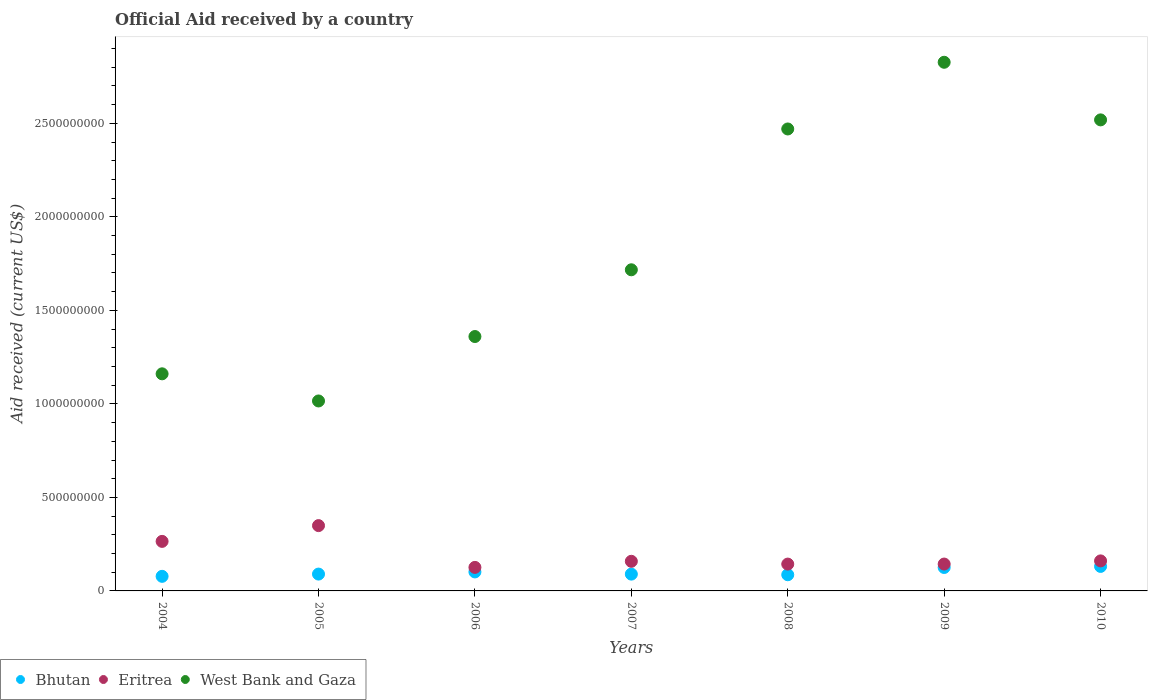How many different coloured dotlines are there?
Ensure brevity in your answer.  3. What is the net official aid received in West Bank and Gaza in 2007?
Provide a succinct answer. 1.72e+09. Across all years, what is the maximum net official aid received in Eritrea?
Give a very brief answer. 3.49e+08. Across all years, what is the minimum net official aid received in West Bank and Gaza?
Ensure brevity in your answer.  1.02e+09. In which year was the net official aid received in Eritrea minimum?
Keep it short and to the point. 2006. What is the total net official aid received in Eritrea in the graph?
Your answer should be compact. 1.35e+09. What is the difference between the net official aid received in Eritrea in 2007 and that in 2009?
Keep it short and to the point. 1.47e+07. What is the difference between the net official aid received in Eritrea in 2006 and the net official aid received in Bhutan in 2004?
Provide a short and direct response. 4.78e+07. What is the average net official aid received in West Bank and Gaza per year?
Offer a terse response. 1.87e+09. In the year 2009, what is the difference between the net official aid received in Eritrea and net official aid received in Bhutan?
Provide a succinct answer. 1.83e+07. What is the ratio of the net official aid received in West Bank and Gaza in 2005 to that in 2009?
Provide a short and direct response. 0.36. What is the difference between the highest and the second highest net official aid received in West Bank and Gaza?
Keep it short and to the point. 3.08e+08. What is the difference between the highest and the lowest net official aid received in Bhutan?
Offer a terse response. 5.30e+07. Is the sum of the net official aid received in Bhutan in 2005 and 2008 greater than the maximum net official aid received in West Bank and Gaza across all years?
Your response must be concise. No. Is it the case that in every year, the sum of the net official aid received in Eritrea and net official aid received in Bhutan  is greater than the net official aid received in West Bank and Gaza?
Your response must be concise. No. Is the net official aid received in Bhutan strictly less than the net official aid received in Eritrea over the years?
Give a very brief answer. Yes. How many dotlines are there?
Your answer should be very brief. 3. What is the difference between two consecutive major ticks on the Y-axis?
Give a very brief answer. 5.00e+08. Does the graph contain any zero values?
Offer a very short reply. No. Does the graph contain grids?
Offer a terse response. No. How many legend labels are there?
Ensure brevity in your answer.  3. What is the title of the graph?
Provide a succinct answer. Official Aid received by a country. Does "Cabo Verde" appear as one of the legend labels in the graph?
Give a very brief answer. No. What is the label or title of the Y-axis?
Keep it short and to the point. Aid received (current US$). What is the Aid received (current US$) in Bhutan in 2004?
Make the answer very short. 7.80e+07. What is the Aid received (current US$) in Eritrea in 2004?
Offer a terse response. 2.65e+08. What is the Aid received (current US$) in West Bank and Gaza in 2004?
Your response must be concise. 1.16e+09. What is the Aid received (current US$) of Bhutan in 2005?
Provide a succinct answer. 9.00e+07. What is the Aid received (current US$) in Eritrea in 2005?
Your answer should be compact. 3.49e+08. What is the Aid received (current US$) of West Bank and Gaza in 2005?
Offer a terse response. 1.02e+09. What is the Aid received (current US$) in Bhutan in 2006?
Give a very brief answer. 1.02e+08. What is the Aid received (current US$) of Eritrea in 2006?
Provide a short and direct response. 1.26e+08. What is the Aid received (current US$) of West Bank and Gaza in 2006?
Provide a succinct answer. 1.36e+09. What is the Aid received (current US$) in Bhutan in 2007?
Keep it short and to the point. 8.98e+07. What is the Aid received (current US$) in Eritrea in 2007?
Make the answer very short. 1.58e+08. What is the Aid received (current US$) in West Bank and Gaza in 2007?
Offer a very short reply. 1.72e+09. What is the Aid received (current US$) of Bhutan in 2008?
Provide a succinct answer. 8.65e+07. What is the Aid received (current US$) of Eritrea in 2008?
Offer a terse response. 1.43e+08. What is the Aid received (current US$) of West Bank and Gaza in 2008?
Make the answer very short. 2.47e+09. What is the Aid received (current US$) of Bhutan in 2009?
Your answer should be very brief. 1.25e+08. What is the Aid received (current US$) of Eritrea in 2009?
Provide a succinct answer. 1.44e+08. What is the Aid received (current US$) in West Bank and Gaza in 2009?
Make the answer very short. 2.83e+09. What is the Aid received (current US$) in Bhutan in 2010?
Give a very brief answer. 1.31e+08. What is the Aid received (current US$) of Eritrea in 2010?
Keep it short and to the point. 1.61e+08. What is the Aid received (current US$) in West Bank and Gaza in 2010?
Offer a very short reply. 2.52e+09. Across all years, what is the maximum Aid received (current US$) of Bhutan?
Give a very brief answer. 1.31e+08. Across all years, what is the maximum Aid received (current US$) in Eritrea?
Your response must be concise. 3.49e+08. Across all years, what is the maximum Aid received (current US$) in West Bank and Gaza?
Make the answer very short. 2.83e+09. Across all years, what is the minimum Aid received (current US$) of Bhutan?
Offer a terse response. 7.80e+07. Across all years, what is the minimum Aid received (current US$) in Eritrea?
Your answer should be compact. 1.26e+08. Across all years, what is the minimum Aid received (current US$) in West Bank and Gaza?
Ensure brevity in your answer.  1.02e+09. What is the total Aid received (current US$) in Bhutan in the graph?
Your answer should be compact. 7.02e+08. What is the total Aid received (current US$) of Eritrea in the graph?
Your response must be concise. 1.35e+09. What is the total Aid received (current US$) in West Bank and Gaza in the graph?
Your answer should be compact. 1.31e+1. What is the difference between the Aid received (current US$) of Bhutan in 2004 and that in 2005?
Make the answer very short. -1.21e+07. What is the difference between the Aid received (current US$) of Eritrea in 2004 and that in 2005?
Make the answer very short. -8.43e+07. What is the difference between the Aid received (current US$) in West Bank and Gaza in 2004 and that in 2005?
Keep it short and to the point. 1.45e+08. What is the difference between the Aid received (current US$) in Bhutan in 2004 and that in 2006?
Your answer should be very brief. -2.36e+07. What is the difference between the Aid received (current US$) of Eritrea in 2004 and that in 2006?
Offer a very short reply. 1.39e+08. What is the difference between the Aid received (current US$) of West Bank and Gaza in 2004 and that in 2006?
Provide a succinct answer. -1.99e+08. What is the difference between the Aid received (current US$) of Bhutan in 2004 and that in 2007?
Provide a short and direct response. -1.19e+07. What is the difference between the Aid received (current US$) of Eritrea in 2004 and that in 2007?
Provide a short and direct response. 1.07e+08. What is the difference between the Aid received (current US$) in West Bank and Gaza in 2004 and that in 2007?
Your response must be concise. -5.56e+08. What is the difference between the Aid received (current US$) in Bhutan in 2004 and that in 2008?
Keep it short and to the point. -8.56e+06. What is the difference between the Aid received (current US$) of Eritrea in 2004 and that in 2008?
Your answer should be compact. 1.21e+08. What is the difference between the Aid received (current US$) in West Bank and Gaza in 2004 and that in 2008?
Ensure brevity in your answer.  -1.31e+09. What is the difference between the Aid received (current US$) of Bhutan in 2004 and that in 2009?
Keep it short and to the point. -4.74e+07. What is the difference between the Aid received (current US$) of Eritrea in 2004 and that in 2009?
Make the answer very short. 1.21e+08. What is the difference between the Aid received (current US$) of West Bank and Gaza in 2004 and that in 2009?
Give a very brief answer. -1.67e+09. What is the difference between the Aid received (current US$) in Bhutan in 2004 and that in 2010?
Keep it short and to the point. -5.30e+07. What is the difference between the Aid received (current US$) in Eritrea in 2004 and that in 2010?
Offer a terse response. 1.04e+08. What is the difference between the Aid received (current US$) of West Bank and Gaza in 2004 and that in 2010?
Offer a very short reply. -1.36e+09. What is the difference between the Aid received (current US$) in Bhutan in 2005 and that in 2006?
Give a very brief answer. -1.15e+07. What is the difference between the Aid received (current US$) of Eritrea in 2005 and that in 2006?
Your response must be concise. 2.23e+08. What is the difference between the Aid received (current US$) in West Bank and Gaza in 2005 and that in 2006?
Your response must be concise. -3.45e+08. What is the difference between the Aid received (current US$) of Bhutan in 2005 and that in 2007?
Ensure brevity in your answer.  2.20e+05. What is the difference between the Aid received (current US$) in Eritrea in 2005 and that in 2007?
Your answer should be very brief. 1.91e+08. What is the difference between the Aid received (current US$) in West Bank and Gaza in 2005 and that in 2007?
Provide a short and direct response. -7.01e+08. What is the difference between the Aid received (current US$) in Bhutan in 2005 and that in 2008?
Your response must be concise. 3.52e+06. What is the difference between the Aid received (current US$) in Eritrea in 2005 and that in 2008?
Provide a short and direct response. 2.06e+08. What is the difference between the Aid received (current US$) of West Bank and Gaza in 2005 and that in 2008?
Your answer should be compact. -1.45e+09. What is the difference between the Aid received (current US$) of Bhutan in 2005 and that in 2009?
Provide a succinct answer. -3.53e+07. What is the difference between the Aid received (current US$) of Eritrea in 2005 and that in 2009?
Keep it short and to the point. 2.06e+08. What is the difference between the Aid received (current US$) in West Bank and Gaza in 2005 and that in 2009?
Offer a very short reply. -1.81e+09. What is the difference between the Aid received (current US$) of Bhutan in 2005 and that in 2010?
Your answer should be compact. -4.10e+07. What is the difference between the Aid received (current US$) of Eritrea in 2005 and that in 2010?
Give a very brief answer. 1.89e+08. What is the difference between the Aid received (current US$) of West Bank and Gaza in 2005 and that in 2010?
Ensure brevity in your answer.  -1.50e+09. What is the difference between the Aid received (current US$) in Bhutan in 2006 and that in 2007?
Provide a succinct answer. 1.17e+07. What is the difference between the Aid received (current US$) in Eritrea in 2006 and that in 2007?
Provide a short and direct response. -3.26e+07. What is the difference between the Aid received (current US$) in West Bank and Gaza in 2006 and that in 2007?
Keep it short and to the point. -3.57e+08. What is the difference between the Aid received (current US$) in Bhutan in 2006 and that in 2008?
Keep it short and to the point. 1.50e+07. What is the difference between the Aid received (current US$) in Eritrea in 2006 and that in 2008?
Keep it short and to the point. -1.77e+07. What is the difference between the Aid received (current US$) of West Bank and Gaza in 2006 and that in 2008?
Offer a very short reply. -1.11e+09. What is the difference between the Aid received (current US$) in Bhutan in 2006 and that in 2009?
Offer a very short reply. -2.38e+07. What is the difference between the Aid received (current US$) of Eritrea in 2006 and that in 2009?
Give a very brief answer. -1.79e+07. What is the difference between the Aid received (current US$) in West Bank and Gaza in 2006 and that in 2009?
Provide a succinct answer. -1.47e+09. What is the difference between the Aid received (current US$) in Bhutan in 2006 and that in 2010?
Offer a terse response. -2.95e+07. What is the difference between the Aid received (current US$) in Eritrea in 2006 and that in 2010?
Keep it short and to the point. -3.47e+07. What is the difference between the Aid received (current US$) of West Bank and Gaza in 2006 and that in 2010?
Give a very brief answer. -1.16e+09. What is the difference between the Aid received (current US$) of Bhutan in 2007 and that in 2008?
Your answer should be very brief. 3.30e+06. What is the difference between the Aid received (current US$) of Eritrea in 2007 and that in 2008?
Your response must be concise. 1.49e+07. What is the difference between the Aid received (current US$) of West Bank and Gaza in 2007 and that in 2008?
Provide a succinct answer. -7.53e+08. What is the difference between the Aid received (current US$) in Bhutan in 2007 and that in 2009?
Provide a succinct answer. -3.56e+07. What is the difference between the Aid received (current US$) in Eritrea in 2007 and that in 2009?
Make the answer very short. 1.47e+07. What is the difference between the Aid received (current US$) in West Bank and Gaza in 2007 and that in 2009?
Your answer should be compact. -1.11e+09. What is the difference between the Aid received (current US$) of Bhutan in 2007 and that in 2010?
Give a very brief answer. -4.12e+07. What is the difference between the Aid received (current US$) of Eritrea in 2007 and that in 2010?
Your answer should be compact. -2.17e+06. What is the difference between the Aid received (current US$) of West Bank and Gaza in 2007 and that in 2010?
Your answer should be very brief. -8.02e+08. What is the difference between the Aid received (current US$) in Bhutan in 2008 and that in 2009?
Make the answer very short. -3.88e+07. What is the difference between the Aid received (current US$) in West Bank and Gaza in 2008 and that in 2009?
Your response must be concise. -3.57e+08. What is the difference between the Aid received (current US$) of Bhutan in 2008 and that in 2010?
Your answer should be compact. -4.45e+07. What is the difference between the Aid received (current US$) of Eritrea in 2008 and that in 2010?
Ensure brevity in your answer.  -1.71e+07. What is the difference between the Aid received (current US$) in West Bank and Gaza in 2008 and that in 2010?
Keep it short and to the point. -4.86e+07. What is the difference between the Aid received (current US$) in Bhutan in 2009 and that in 2010?
Keep it short and to the point. -5.62e+06. What is the difference between the Aid received (current US$) of Eritrea in 2009 and that in 2010?
Ensure brevity in your answer.  -1.68e+07. What is the difference between the Aid received (current US$) in West Bank and Gaza in 2009 and that in 2010?
Give a very brief answer. 3.08e+08. What is the difference between the Aid received (current US$) in Bhutan in 2004 and the Aid received (current US$) in Eritrea in 2005?
Your answer should be very brief. -2.71e+08. What is the difference between the Aid received (current US$) in Bhutan in 2004 and the Aid received (current US$) in West Bank and Gaza in 2005?
Provide a short and direct response. -9.38e+08. What is the difference between the Aid received (current US$) in Eritrea in 2004 and the Aid received (current US$) in West Bank and Gaza in 2005?
Keep it short and to the point. -7.51e+08. What is the difference between the Aid received (current US$) of Bhutan in 2004 and the Aid received (current US$) of Eritrea in 2006?
Offer a very short reply. -4.78e+07. What is the difference between the Aid received (current US$) in Bhutan in 2004 and the Aid received (current US$) in West Bank and Gaza in 2006?
Give a very brief answer. -1.28e+09. What is the difference between the Aid received (current US$) in Eritrea in 2004 and the Aid received (current US$) in West Bank and Gaza in 2006?
Provide a short and direct response. -1.10e+09. What is the difference between the Aid received (current US$) in Bhutan in 2004 and the Aid received (current US$) in Eritrea in 2007?
Offer a terse response. -8.04e+07. What is the difference between the Aid received (current US$) of Bhutan in 2004 and the Aid received (current US$) of West Bank and Gaza in 2007?
Offer a terse response. -1.64e+09. What is the difference between the Aid received (current US$) in Eritrea in 2004 and the Aid received (current US$) in West Bank and Gaza in 2007?
Offer a terse response. -1.45e+09. What is the difference between the Aid received (current US$) in Bhutan in 2004 and the Aid received (current US$) in Eritrea in 2008?
Your answer should be compact. -6.55e+07. What is the difference between the Aid received (current US$) in Bhutan in 2004 and the Aid received (current US$) in West Bank and Gaza in 2008?
Give a very brief answer. -2.39e+09. What is the difference between the Aid received (current US$) of Eritrea in 2004 and the Aid received (current US$) of West Bank and Gaza in 2008?
Give a very brief answer. -2.21e+09. What is the difference between the Aid received (current US$) in Bhutan in 2004 and the Aid received (current US$) in Eritrea in 2009?
Provide a succinct answer. -6.57e+07. What is the difference between the Aid received (current US$) in Bhutan in 2004 and the Aid received (current US$) in West Bank and Gaza in 2009?
Your answer should be very brief. -2.75e+09. What is the difference between the Aid received (current US$) in Eritrea in 2004 and the Aid received (current US$) in West Bank and Gaza in 2009?
Ensure brevity in your answer.  -2.56e+09. What is the difference between the Aid received (current US$) in Bhutan in 2004 and the Aid received (current US$) in Eritrea in 2010?
Offer a terse response. -8.26e+07. What is the difference between the Aid received (current US$) of Bhutan in 2004 and the Aid received (current US$) of West Bank and Gaza in 2010?
Offer a terse response. -2.44e+09. What is the difference between the Aid received (current US$) in Eritrea in 2004 and the Aid received (current US$) in West Bank and Gaza in 2010?
Your answer should be compact. -2.25e+09. What is the difference between the Aid received (current US$) in Bhutan in 2005 and the Aid received (current US$) in Eritrea in 2006?
Keep it short and to the point. -3.58e+07. What is the difference between the Aid received (current US$) of Bhutan in 2005 and the Aid received (current US$) of West Bank and Gaza in 2006?
Make the answer very short. -1.27e+09. What is the difference between the Aid received (current US$) of Eritrea in 2005 and the Aid received (current US$) of West Bank and Gaza in 2006?
Offer a very short reply. -1.01e+09. What is the difference between the Aid received (current US$) in Bhutan in 2005 and the Aid received (current US$) in Eritrea in 2007?
Provide a short and direct response. -6.83e+07. What is the difference between the Aid received (current US$) in Bhutan in 2005 and the Aid received (current US$) in West Bank and Gaza in 2007?
Your answer should be very brief. -1.63e+09. What is the difference between the Aid received (current US$) in Eritrea in 2005 and the Aid received (current US$) in West Bank and Gaza in 2007?
Provide a short and direct response. -1.37e+09. What is the difference between the Aid received (current US$) in Bhutan in 2005 and the Aid received (current US$) in Eritrea in 2008?
Your answer should be compact. -5.34e+07. What is the difference between the Aid received (current US$) of Bhutan in 2005 and the Aid received (current US$) of West Bank and Gaza in 2008?
Offer a very short reply. -2.38e+09. What is the difference between the Aid received (current US$) of Eritrea in 2005 and the Aid received (current US$) of West Bank and Gaza in 2008?
Provide a succinct answer. -2.12e+09. What is the difference between the Aid received (current US$) of Bhutan in 2005 and the Aid received (current US$) of Eritrea in 2009?
Your answer should be very brief. -5.36e+07. What is the difference between the Aid received (current US$) of Bhutan in 2005 and the Aid received (current US$) of West Bank and Gaza in 2009?
Your answer should be very brief. -2.74e+09. What is the difference between the Aid received (current US$) in Eritrea in 2005 and the Aid received (current US$) in West Bank and Gaza in 2009?
Keep it short and to the point. -2.48e+09. What is the difference between the Aid received (current US$) of Bhutan in 2005 and the Aid received (current US$) of Eritrea in 2010?
Give a very brief answer. -7.05e+07. What is the difference between the Aid received (current US$) of Bhutan in 2005 and the Aid received (current US$) of West Bank and Gaza in 2010?
Keep it short and to the point. -2.43e+09. What is the difference between the Aid received (current US$) in Eritrea in 2005 and the Aid received (current US$) in West Bank and Gaza in 2010?
Offer a terse response. -2.17e+09. What is the difference between the Aid received (current US$) of Bhutan in 2006 and the Aid received (current US$) of Eritrea in 2007?
Keep it short and to the point. -5.68e+07. What is the difference between the Aid received (current US$) of Bhutan in 2006 and the Aid received (current US$) of West Bank and Gaza in 2007?
Offer a terse response. -1.62e+09. What is the difference between the Aid received (current US$) of Eritrea in 2006 and the Aid received (current US$) of West Bank and Gaza in 2007?
Offer a very short reply. -1.59e+09. What is the difference between the Aid received (current US$) in Bhutan in 2006 and the Aid received (current US$) in Eritrea in 2008?
Your response must be concise. -4.19e+07. What is the difference between the Aid received (current US$) of Bhutan in 2006 and the Aid received (current US$) of West Bank and Gaza in 2008?
Give a very brief answer. -2.37e+09. What is the difference between the Aid received (current US$) in Eritrea in 2006 and the Aid received (current US$) in West Bank and Gaza in 2008?
Offer a very short reply. -2.34e+09. What is the difference between the Aid received (current US$) of Bhutan in 2006 and the Aid received (current US$) of Eritrea in 2009?
Give a very brief answer. -4.22e+07. What is the difference between the Aid received (current US$) in Bhutan in 2006 and the Aid received (current US$) in West Bank and Gaza in 2009?
Your response must be concise. -2.73e+09. What is the difference between the Aid received (current US$) in Eritrea in 2006 and the Aid received (current US$) in West Bank and Gaza in 2009?
Provide a succinct answer. -2.70e+09. What is the difference between the Aid received (current US$) of Bhutan in 2006 and the Aid received (current US$) of Eritrea in 2010?
Offer a terse response. -5.90e+07. What is the difference between the Aid received (current US$) of Bhutan in 2006 and the Aid received (current US$) of West Bank and Gaza in 2010?
Provide a succinct answer. -2.42e+09. What is the difference between the Aid received (current US$) in Eritrea in 2006 and the Aid received (current US$) in West Bank and Gaza in 2010?
Your response must be concise. -2.39e+09. What is the difference between the Aid received (current US$) of Bhutan in 2007 and the Aid received (current US$) of Eritrea in 2008?
Give a very brief answer. -5.36e+07. What is the difference between the Aid received (current US$) in Bhutan in 2007 and the Aid received (current US$) in West Bank and Gaza in 2008?
Offer a very short reply. -2.38e+09. What is the difference between the Aid received (current US$) of Eritrea in 2007 and the Aid received (current US$) of West Bank and Gaza in 2008?
Ensure brevity in your answer.  -2.31e+09. What is the difference between the Aid received (current US$) of Bhutan in 2007 and the Aid received (current US$) of Eritrea in 2009?
Keep it short and to the point. -5.39e+07. What is the difference between the Aid received (current US$) in Bhutan in 2007 and the Aid received (current US$) in West Bank and Gaza in 2009?
Provide a short and direct response. -2.74e+09. What is the difference between the Aid received (current US$) in Eritrea in 2007 and the Aid received (current US$) in West Bank and Gaza in 2009?
Ensure brevity in your answer.  -2.67e+09. What is the difference between the Aid received (current US$) of Bhutan in 2007 and the Aid received (current US$) of Eritrea in 2010?
Give a very brief answer. -7.07e+07. What is the difference between the Aid received (current US$) of Bhutan in 2007 and the Aid received (current US$) of West Bank and Gaza in 2010?
Provide a succinct answer. -2.43e+09. What is the difference between the Aid received (current US$) of Eritrea in 2007 and the Aid received (current US$) of West Bank and Gaza in 2010?
Your answer should be very brief. -2.36e+09. What is the difference between the Aid received (current US$) of Bhutan in 2008 and the Aid received (current US$) of Eritrea in 2009?
Make the answer very short. -5.72e+07. What is the difference between the Aid received (current US$) in Bhutan in 2008 and the Aid received (current US$) in West Bank and Gaza in 2009?
Offer a terse response. -2.74e+09. What is the difference between the Aid received (current US$) in Eritrea in 2008 and the Aid received (current US$) in West Bank and Gaza in 2009?
Offer a very short reply. -2.68e+09. What is the difference between the Aid received (current US$) in Bhutan in 2008 and the Aid received (current US$) in Eritrea in 2010?
Make the answer very short. -7.40e+07. What is the difference between the Aid received (current US$) in Bhutan in 2008 and the Aid received (current US$) in West Bank and Gaza in 2010?
Offer a terse response. -2.43e+09. What is the difference between the Aid received (current US$) of Eritrea in 2008 and the Aid received (current US$) of West Bank and Gaza in 2010?
Offer a very short reply. -2.38e+09. What is the difference between the Aid received (current US$) in Bhutan in 2009 and the Aid received (current US$) in Eritrea in 2010?
Provide a short and direct response. -3.52e+07. What is the difference between the Aid received (current US$) of Bhutan in 2009 and the Aid received (current US$) of West Bank and Gaza in 2010?
Provide a succinct answer. -2.39e+09. What is the difference between the Aid received (current US$) in Eritrea in 2009 and the Aid received (current US$) in West Bank and Gaza in 2010?
Make the answer very short. -2.38e+09. What is the average Aid received (current US$) of Bhutan per year?
Your answer should be very brief. 1.00e+08. What is the average Aid received (current US$) of Eritrea per year?
Make the answer very short. 1.92e+08. What is the average Aid received (current US$) in West Bank and Gaza per year?
Make the answer very short. 1.87e+09. In the year 2004, what is the difference between the Aid received (current US$) in Bhutan and Aid received (current US$) in Eritrea?
Offer a terse response. -1.87e+08. In the year 2004, what is the difference between the Aid received (current US$) in Bhutan and Aid received (current US$) in West Bank and Gaza?
Offer a very short reply. -1.08e+09. In the year 2004, what is the difference between the Aid received (current US$) in Eritrea and Aid received (current US$) in West Bank and Gaza?
Offer a very short reply. -8.96e+08. In the year 2005, what is the difference between the Aid received (current US$) in Bhutan and Aid received (current US$) in Eritrea?
Provide a short and direct response. -2.59e+08. In the year 2005, what is the difference between the Aid received (current US$) in Bhutan and Aid received (current US$) in West Bank and Gaza?
Your answer should be compact. -9.26e+08. In the year 2005, what is the difference between the Aid received (current US$) in Eritrea and Aid received (current US$) in West Bank and Gaza?
Make the answer very short. -6.66e+08. In the year 2006, what is the difference between the Aid received (current US$) of Bhutan and Aid received (current US$) of Eritrea?
Ensure brevity in your answer.  -2.43e+07. In the year 2006, what is the difference between the Aid received (current US$) in Bhutan and Aid received (current US$) in West Bank and Gaza?
Ensure brevity in your answer.  -1.26e+09. In the year 2006, what is the difference between the Aid received (current US$) in Eritrea and Aid received (current US$) in West Bank and Gaza?
Your answer should be compact. -1.23e+09. In the year 2007, what is the difference between the Aid received (current US$) in Bhutan and Aid received (current US$) in Eritrea?
Provide a succinct answer. -6.85e+07. In the year 2007, what is the difference between the Aid received (current US$) in Bhutan and Aid received (current US$) in West Bank and Gaza?
Ensure brevity in your answer.  -1.63e+09. In the year 2007, what is the difference between the Aid received (current US$) in Eritrea and Aid received (current US$) in West Bank and Gaza?
Provide a succinct answer. -1.56e+09. In the year 2008, what is the difference between the Aid received (current US$) in Bhutan and Aid received (current US$) in Eritrea?
Ensure brevity in your answer.  -5.70e+07. In the year 2008, what is the difference between the Aid received (current US$) of Bhutan and Aid received (current US$) of West Bank and Gaza?
Offer a very short reply. -2.38e+09. In the year 2008, what is the difference between the Aid received (current US$) in Eritrea and Aid received (current US$) in West Bank and Gaza?
Keep it short and to the point. -2.33e+09. In the year 2009, what is the difference between the Aid received (current US$) in Bhutan and Aid received (current US$) in Eritrea?
Offer a terse response. -1.83e+07. In the year 2009, what is the difference between the Aid received (current US$) of Bhutan and Aid received (current US$) of West Bank and Gaza?
Provide a succinct answer. -2.70e+09. In the year 2009, what is the difference between the Aid received (current US$) in Eritrea and Aid received (current US$) in West Bank and Gaza?
Your answer should be compact. -2.68e+09. In the year 2010, what is the difference between the Aid received (current US$) of Bhutan and Aid received (current US$) of Eritrea?
Provide a succinct answer. -2.95e+07. In the year 2010, what is the difference between the Aid received (current US$) in Bhutan and Aid received (current US$) in West Bank and Gaza?
Your answer should be very brief. -2.39e+09. In the year 2010, what is the difference between the Aid received (current US$) of Eritrea and Aid received (current US$) of West Bank and Gaza?
Your answer should be very brief. -2.36e+09. What is the ratio of the Aid received (current US$) of Bhutan in 2004 to that in 2005?
Provide a short and direct response. 0.87. What is the ratio of the Aid received (current US$) of Eritrea in 2004 to that in 2005?
Offer a terse response. 0.76. What is the ratio of the Aid received (current US$) in Bhutan in 2004 to that in 2006?
Ensure brevity in your answer.  0.77. What is the ratio of the Aid received (current US$) in Eritrea in 2004 to that in 2006?
Your answer should be compact. 2.11. What is the ratio of the Aid received (current US$) in West Bank and Gaza in 2004 to that in 2006?
Make the answer very short. 0.85. What is the ratio of the Aid received (current US$) of Bhutan in 2004 to that in 2007?
Make the answer very short. 0.87. What is the ratio of the Aid received (current US$) of Eritrea in 2004 to that in 2007?
Your response must be concise. 1.67. What is the ratio of the Aid received (current US$) of West Bank and Gaza in 2004 to that in 2007?
Offer a very short reply. 0.68. What is the ratio of the Aid received (current US$) in Bhutan in 2004 to that in 2008?
Keep it short and to the point. 0.9. What is the ratio of the Aid received (current US$) of Eritrea in 2004 to that in 2008?
Offer a very short reply. 1.85. What is the ratio of the Aid received (current US$) of West Bank and Gaza in 2004 to that in 2008?
Give a very brief answer. 0.47. What is the ratio of the Aid received (current US$) in Bhutan in 2004 to that in 2009?
Make the answer very short. 0.62. What is the ratio of the Aid received (current US$) in Eritrea in 2004 to that in 2009?
Ensure brevity in your answer.  1.84. What is the ratio of the Aid received (current US$) of West Bank and Gaza in 2004 to that in 2009?
Give a very brief answer. 0.41. What is the ratio of the Aid received (current US$) of Bhutan in 2004 to that in 2010?
Offer a very short reply. 0.6. What is the ratio of the Aid received (current US$) of Eritrea in 2004 to that in 2010?
Offer a terse response. 1.65. What is the ratio of the Aid received (current US$) in West Bank and Gaza in 2004 to that in 2010?
Make the answer very short. 0.46. What is the ratio of the Aid received (current US$) in Bhutan in 2005 to that in 2006?
Make the answer very short. 0.89. What is the ratio of the Aid received (current US$) in Eritrea in 2005 to that in 2006?
Offer a very short reply. 2.78. What is the ratio of the Aid received (current US$) of West Bank and Gaza in 2005 to that in 2006?
Offer a very short reply. 0.75. What is the ratio of the Aid received (current US$) in Bhutan in 2005 to that in 2007?
Offer a very short reply. 1. What is the ratio of the Aid received (current US$) of Eritrea in 2005 to that in 2007?
Provide a succinct answer. 2.21. What is the ratio of the Aid received (current US$) of West Bank and Gaza in 2005 to that in 2007?
Ensure brevity in your answer.  0.59. What is the ratio of the Aid received (current US$) in Bhutan in 2005 to that in 2008?
Offer a very short reply. 1.04. What is the ratio of the Aid received (current US$) in Eritrea in 2005 to that in 2008?
Ensure brevity in your answer.  2.43. What is the ratio of the Aid received (current US$) in West Bank and Gaza in 2005 to that in 2008?
Ensure brevity in your answer.  0.41. What is the ratio of the Aid received (current US$) in Bhutan in 2005 to that in 2009?
Ensure brevity in your answer.  0.72. What is the ratio of the Aid received (current US$) in Eritrea in 2005 to that in 2009?
Make the answer very short. 2.43. What is the ratio of the Aid received (current US$) of West Bank and Gaza in 2005 to that in 2009?
Give a very brief answer. 0.36. What is the ratio of the Aid received (current US$) of Bhutan in 2005 to that in 2010?
Offer a very short reply. 0.69. What is the ratio of the Aid received (current US$) in Eritrea in 2005 to that in 2010?
Provide a succinct answer. 2.18. What is the ratio of the Aid received (current US$) in West Bank and Gaza in 2005 to that in 2010?
Your answer should be compact. 0.4. What is the ratio of the Aid received (current US$) in Bhutan in 2006 to that in 2007?
Make the answer very short. 1.13. What is the ratio of the Aid received (current US$) in Eritrea in 2006 to that in 2007?
Give a very brief answer. 0.79. What is the ratio of the Aid received (current US$) of West Bank and Gaza in 2006 to that in 2007?
Provide a short and direct response. 0.79. What is the ratio of the Aid received (current US$) in Bhutan in 2006 to that in 2008?
Your response must be concise. 1.17. What is the ratio of the Aid received (current US$) in Eritrea in 2006 to that in 2008?
Keep it short and to the point. 0.88. What is the ratio of the Aid received (current US$) of West Bank and Gaza in 2006 to that in 2008?
Ensure brevity in your answer.  0.55. What is the ratio of the Aid received (current US$) in Bhutan in 2006 to that in 2009?
Offer a very short reply. 0.81. What is the ratio of the Aid received (current US$) in Eritrea in 2006 to that in 2009?
Offer a terse response. 0.88. What is the ratio of the Aid received (current US$) of West Bank and Gaza in 2006 to that in 2009?
Give a very brief answer. 0.48. What is the ratio of the Aid received (current US$) in Bhutan in 2006 to that in 2010?
Keep it short and to the point. 0.78. What is the ratio of the Aid received (current US$) in Eritrea in 2006 to that in 2010?
Offer a terse response. 0.78. What is the ratio of the Aid received (current US$) in West Bank and Gaza in 2006 to that in 2010?
Provide a succinct answer. 0.54. What is the ratio of the Aid received (current US$) in Bhutan in 2007 to that in 2008?
Ensure brevity in your answer.  1.04. What is the ratio of the Aid received (current US$) in Eritrea in 2007 to that in 2008?
Give a very brief answer. 1.1. What is the ratio of the Aid received (current US$) of West Bank and Gaza in 2007 to that in 2008?
Offer a very short reply. 0.7. What is the ratio of the Aid received (current US$) in Bhutan in 2007 to that in 2009?
Give a very brief answer. 0.72. What is the ratio of the Aid received (current US$) in Eritrea in 2007 to that in 2009?
Provide a succinct answer. 1.1. What is the ratio of the Aid received (current US$) in West Bank and Gaza in 2007 to that in 2009?
Give a very brief answer. 0.61. What is the ratio of the Aid received (current US$) in Bhutan in 2007 to that in 2010?
Your answer should be compact. 0.69. What is the ratio of the Aid received (current US$) in Eritrea in 2007 to that in 2010?
Provide a succinct answer. 0.99. What is the ratio of the Aid received (current US$) of West Bank and Gaza in 2007 to that in 2010?
Give a very brief answer. 0.68. What is the ratio of the Aid received (current US$) of Bhutan in 2008 to that in 2009?
Offer a terse response. 0.69. What is the ratio of the Aid received (current US$) of Eritrea in 2008 to that in 2009?
Your response must be concise. 1. What is the ratio of the Aid received (current US$) of West Bank and Gaza in 2008 to that in 2009?
Offer a terse response. 0.87. What is the ratio of the Aid received (current US$) in Bhutan in 2008 to that in 2010?
Your response must be concise. 0.66. What is the ratio of the Aid received (current US$) of Eritrea in 2008 to that in 2010?
Your response must be concise. 0.89. What is the ratio of the Aid received (current US$) of West Bank and Gaza in 2008 to that in 2010?
Give a very brief answer. 0.98. What is the ratio of the Aid received (current US$) of Bhutan in 2009 to that in 2010?
Your answer should be compact. 0.96. What is the ratio of the Aid received (current US$) in Eritrea in 2009 to that in 2010?
Your answer should be compact. 0.9. What is the ratio of the Aid received (current US$) of West Bank and Gaza in 2009 to that in 2010?
Keep it short and to the point. 1.12. What is the difference between the highest and the second highest Aid received (current US$) in Bhutan?
Make the answer very short. 5.62e+06. What is the difference between the highest and the second highest Aid received (current US$) of Eritrea?
Your answer should be very brief. 8.43e+07. What is the difference between the highest and the second highest Aid received (current US$) of West Bank and Gaza?
Make the answer very short. 3.08e+08. What is the difference between the highest and the lowest Aid received (current US$) of Bhutan?
Offer a terse response. 5.30e+07. What is the difference between the highest and the lowest Aid received (current US$) in Eritrea?
Make the answer very short. 2.23e+08. What is the difference between the highest and the lowest Aid received (current US$) of West Bank and Gaza?
Make the answer very short. 1.81e+09. 